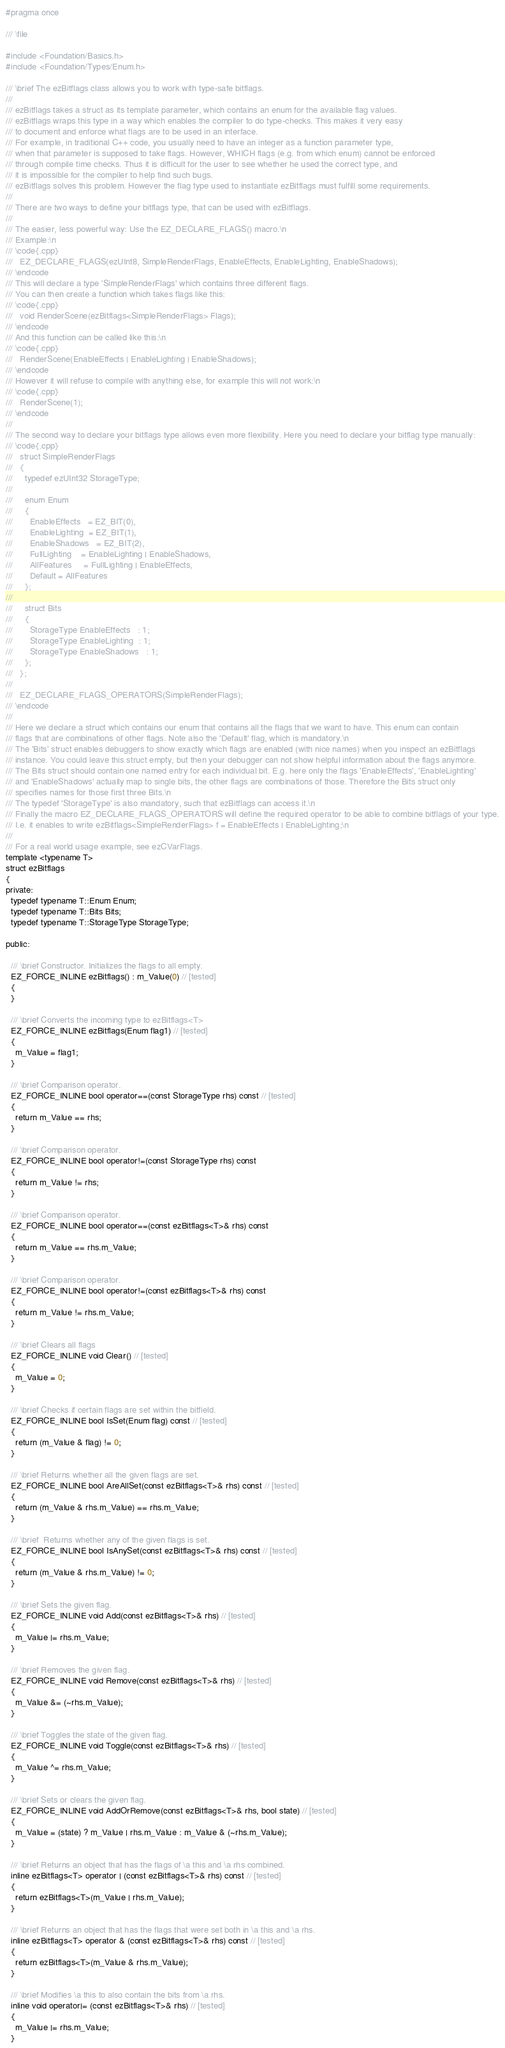Convert code to text. <code><loc_0><loc_0><loc_500><loc_500><_C_>#pragma once

/// \file

#include <Foundation/Basics.h>
#include <Foundation/Types/Enum.h>

/// \brief The ezBitflags class allows you to work with type-safe bitflags.
///
/// ezBitflags takes a struct as its template parameter, which contains an enum for the available flag values.
/// ezBitflags wraps this type in a way which enables the compiler to do type-checks. This makes it very easy
/// to document and enforce what flags are to be used in an interface.
/// For example, in traditional C++ code, you usually need to have an integer as a function parameter type,
/// when that parameter is supposed to take flags. However, WHICH flags (e.g. from which enum) cannot be enforced
/// through compile time checks. Thus it is difficult for the user to see whether he used the correct type, and
/// it is impossible for the compiler to help find such bugs.
/// ezBitflags solves this problem. However the flag type used to instantiate ezBitflags must fulfill some requirements.
///
/// There are two ways to define your bitflags type, that can be used with ezBitflags.
///
/// The easier, less powerful way: Use the EZ_DECLARE_FLAGS() macro.\n
/// Example:\n
/// \code{.cpp}
///   EZ_DECLARE_FLAGS(ezUInt8, SimpleRenderFlags, EnableEffects, EnableLighting, EnableShadows);
/// \endcode
/// This will declare a type 'SimpleRenderFlags' which contains three different flags.
/// You can then create a function which takes flags like this:
/// \code{.cpp}
///   void RenderScene(ezBitflags<SimpleRenderFlags> Flags);
/// \endcode
/// And this function can be called like this:\n
/// \code{.cpp}
///   RenderScene(EnableEffects | EnableLighting | EnableShadows);
/// \endcode
/// However it will refuse to compile with anything else, for example this will not work:\n
/// \code{.cpp}
///   RenderScene(1);
/// \endcode
///
/// The second way to declare your bitflags type allows even more flexibility. Here you need to declare your bitflag type manually:
/// \code{.cpp}
///   struct SimpleRenderFlags
///   {
///     typedef ezUInt32 StorageType;
///
///     enum Enum
///     {
///       EnableEffects   = EZ_BIT(0),
///       EnableLighting  = EZ_BIT(1),
///       EnableShadows   = EZ_BIT(2),
///       FullLighting    = EnableLighting | EnableShadows,
///       AllFeatures     = FullLighting | EnableEffects,
///       Default = AllFeatures
///     };
///
///     struct Bits
///     {
///       StorageType EnableEffects   : 1;
///       StorageType EnableLighting  : 1;
///       StorageType EnableShadows   : 1;
///     };
///   };
///
///   EZ_DECLARE_FLAGS_OPERATORS(SimpleRenderFlags);
/// \endcode
///
/// Here we declare a struct which contains our enum that contains all the flags that we want to have. This enum can contain
/// flags that are combinations of other flags. Note also the 'Default' flag, which is mandatory.\n
/// The 'Bits' struct enables debuggers to show exactly which flags are enabled (with nice names) when you inspect an ezBitflags
/// instance. You could leave this struct empty, but then your debugger can not show helpful information about the flags anymore.
/// The Bits struct should contain one named entry for each individual bit. E.g. here only the flags 'EnableEffects', 'EnableLighting'
/// and 'EnableShadows' actually map to single bits, the other flags are combinations of those. Therefore the Bits struct only
/// specifies names for those first three Bits.\n
/// The typedef 'StorageType' is also mandatory, such that ezBitflags can access it.\n
/// Finally the macro EZ_DECLARE_FLAGS_OPERATORS will define the required operator to be able to combine bitflags of your type.
/// I.e. it enables to write ezBitflags<SimpleRenderFlags> f = EnableEffects | EnableLighting;\n
///
/// For a real world usage example, see ezCVarFlags.
template <typename T>
struct ezBitflags
{
private:
  typedef typename T::Enum Enum;
  typedef typename T::Bits Bits;
  typedef typename T::StorageType StorageType;

public:
    
  /// \brief Constructor. Initializes the flags to all empty.
  EZ_FORCE_INLINE ezBitflags() : m_Value(0) // [tested]
  {
  }

  /// \brief Converts the incoming type to ezBitflags<T>
  EZ_FORCE_INLINE ezBitflags(Enum flag1) // [tested]
  {
    m_Value = flag1;
  }

  /// \brief Comparison operator.
  EZ_FORCE_INLINE bool operator==(const StorageType rhs) const // [tested]
  {
    return m_Value == rhs;
  }

  /// \brief Comparison operator.
  EZ_FORCE_INLINE bool operator!=(const StorageType rhs) const
  {
    return m_Value != rhs;
  }

  /// \brief Comparison operator.
  EZ_FORCE_INLINE bool operator==(const ezBitflags<T>& rhs) const
  {
    return m_Value == rhs.m_Value;
  }

  /// \brief Comparison operator.
  EZ_FORCE_INLINE bool operator!=(const ezBitflags<T>& rhs) const
  {
    return m_Value != rhs.m_Value;
  }

  /// \brief Clears all flags
  EZ_FORCE_INLINE void Clear() // [tested]
  {
    m_Value = 0;
  }

  /// \brief Checks if certain flags are set within the bitfield.
  EZ_FORCE_INLINE bool IsSet(Enum flag) const // [tested]
  {
    return (m_Value & flag) != 0;
  }
  
  /// \brief Returns whether all the given flags are set.
  EZ_FORCE_INLINE bool AreAllSet(const ezBitflags<T>& rhs) const // [tested]
  {
    return (m_Value & rhs.m_Value) == rhs.m_Value;
  }

  /// \brief  Returns whether any of the given flags is set.
  EZ_FORCE_INLINE bool IsAnySet(const ezBitflags<T>& rhs) const // [tested]
  {
    return (m_Value & rhs.m_Value) != 0;
  }

  /// \brief Sets the given flag.
  EZ_FORCE_INLINE void Add(const ezBitflags<T>& rhs) // [tested]
  {
    m_Value |= rhs.m_Value;
  }

  /// \brief Removes the given flag.
  EZ_FORCE_INLINE void Remove(const ezBitflags<T>& rhs) // [tested]
  {
    m_Value &= (~rhs.m_Value);
  }

  /// \brief Toggles the state of the given flag.
  EZ_FORCE_INLINE void Toggle(const ezBitflags<T>& rhs) // [tested]
  {
    m_Value ^= rhs.m_Value;
  }

  /// \brief Sets or clears the given flag.
  EZ_FORCE_INLINE void AddOrRemove(const ezBitflags<T>& rhs, bool state) // [tested]
  {
    m_Value = (state) ? m_Value | rhs.m_Value : m_Value & (~rhs.m_Value);
  }

  /// \brief Returns an object that has the flags of \a this and \a rhs combined.
  inline ezBitflags<T> operator | (const ezBitflags<T>& rhs) const // [tested]
  {
    return ezBitflags<T>(m_Value | rhs.m_Value);
  }

  /// \brief Returns an object that has the flags that were set both in \a this and \a rhs.
  inline ezBitflags<T> operator & (const ezBitflags<T>& rhs) const // [tested]
  {
    return ezBitflags<T>(m_Value & rhs.m_Value);
  }

  /// \brief Modifies \a this to also contain the bits from \a rhs.
  inline void operator|= (const ezBitflags<T>& rhs) // [tested]
  {
    m_Value |= rhs.m_Value;
  }
</code> 